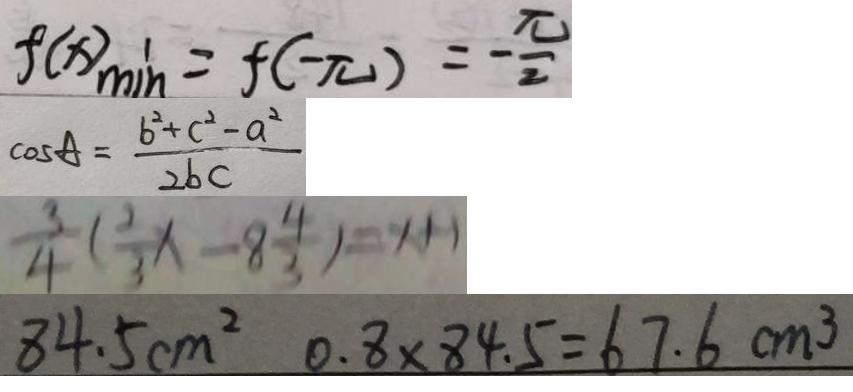Convert formula to latex. <formula><loc_0><loc_0><loc_500><loc_500>f ( x ) _ { \min } = f ( - \pi ) = - \frac { \pi } { 2 } 
 \cos A = \frac { b ^ { 2 } + c ^ { 2 } - a ^ { 2 } } { 2 b c } 
 \frac { 3 } { 4 } ( \frac { 2 } { 3 } x - 8 \frac { 4 } { 3 } ) = x + 1 
 8 4 . 5 c m ^ { 2 } 0 . 8 \times 8 4 . 5 = 6 7 . 6 c m ^ { 3 }</formula> 